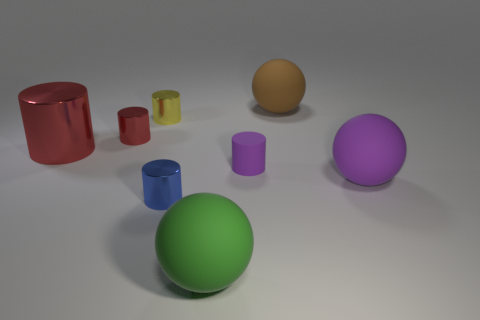Subtract all yellow blocks. How many red cylinders are left? 2 Subtract all yellow cylinders. How many cylinders are left? 4 Subtract all red cylinders. How many cylinders are left? 3 Add 2 big cylinders. How many objects exist? 10 Subtract all cylinders. How many objects are left? 3 Add 4 big metallic things. How many big metallic things are left? 5 Add 1 big spheres. How many big spheres exist? 4 Subtract 0 cyan spheres. How many objects are left? 8 Subtract all red cylinders. Subtract all green spheres. How many cylinders are left? 3 Subtract all large green spheres. Subtract all tiny yellow cylinders. How many objects are left? 6 